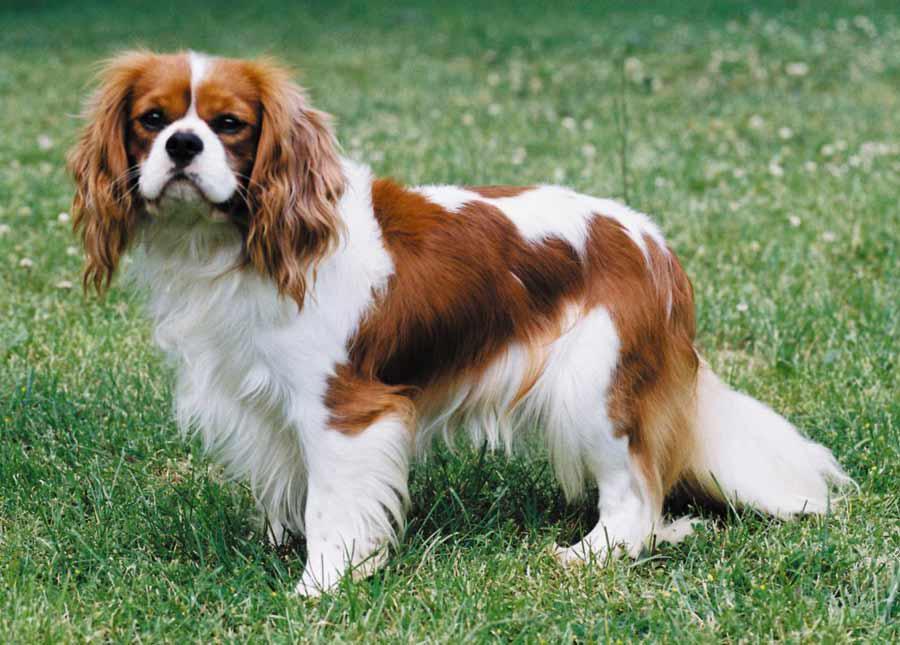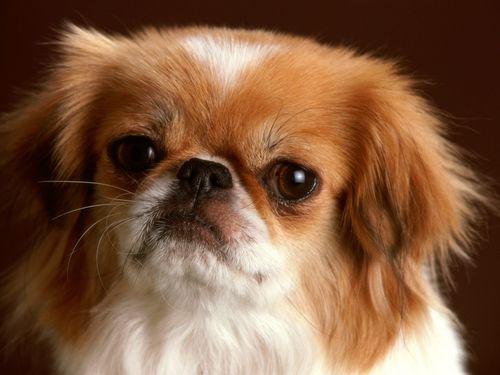The first image is the image on the left, the second image is the image on the right. Assess this claim about the two images: "At least one animal is on the grass.". Correct or not? Answer yes or no. Yes. 